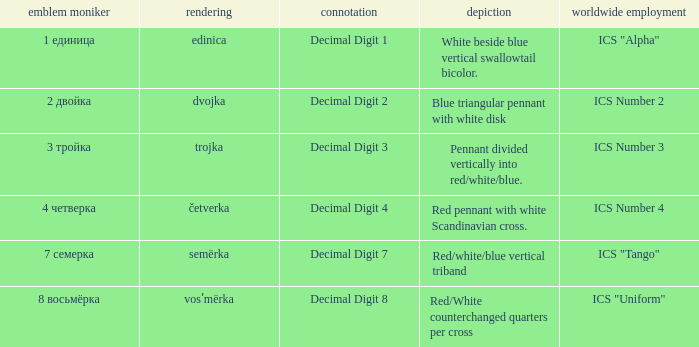What are the meanings of the flag whose name transliterates to semërka? Decimal Digit 7. 